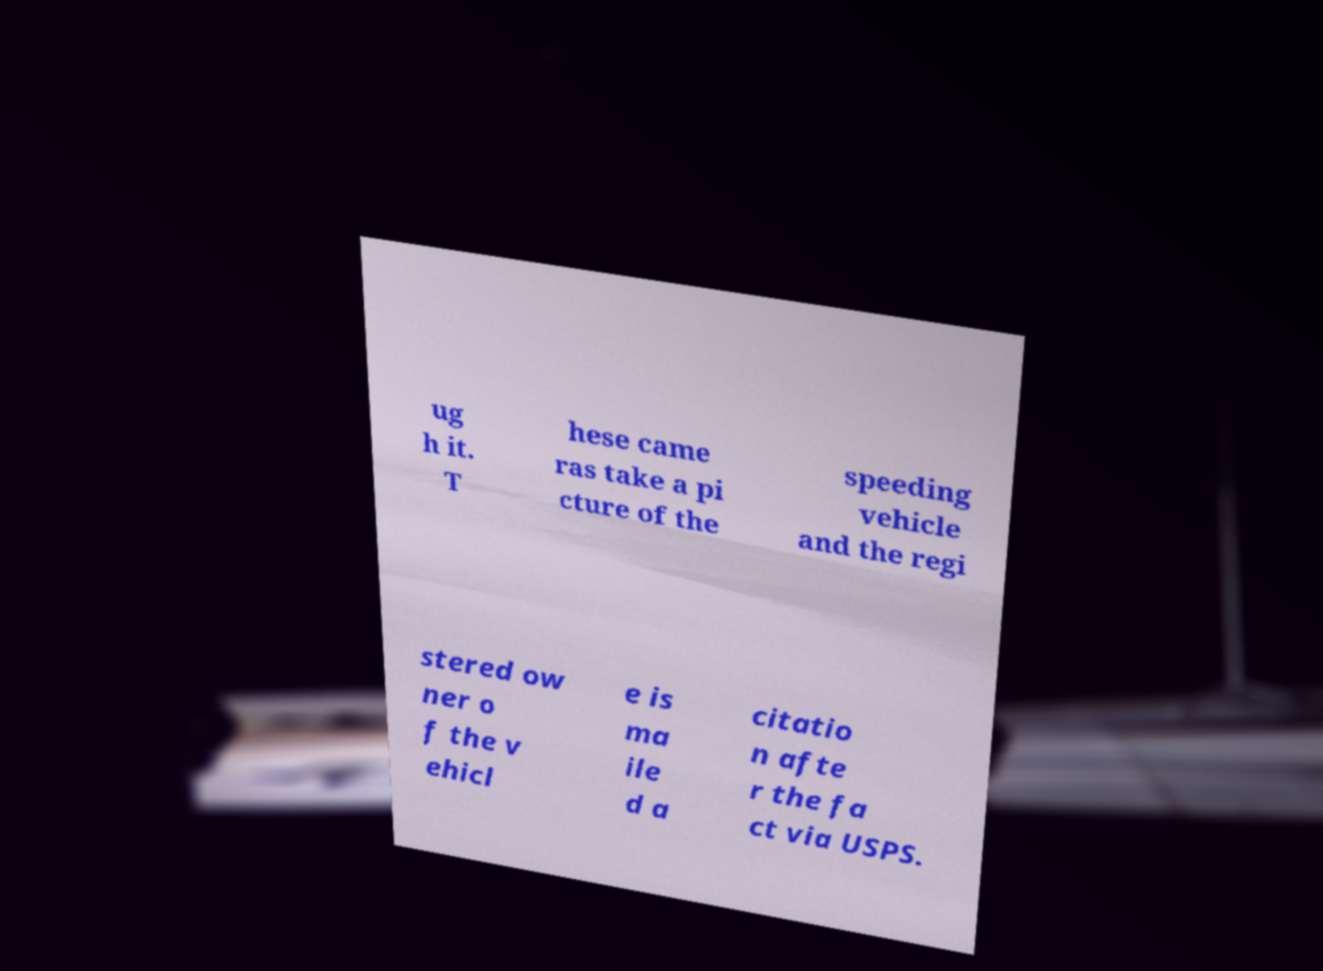I need the written content from this picture converted into text. Can you do that? ug h it. T hese came ras take a pi cture of the speeding vehicle and the regi stered ow ner o f the v ehicl e is ma ile d a citatio n afte r the fa ct via USPS. 